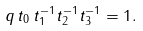<formula> <loc_0><loc_0><loc_500><loc_500>q \, t _ { 0 } \, t _ { 1 } ^ { - 1 } t _ { 2 } ^ { - 1 } t _ { 3 } ^ { - 1 } = 1 .</formula> 